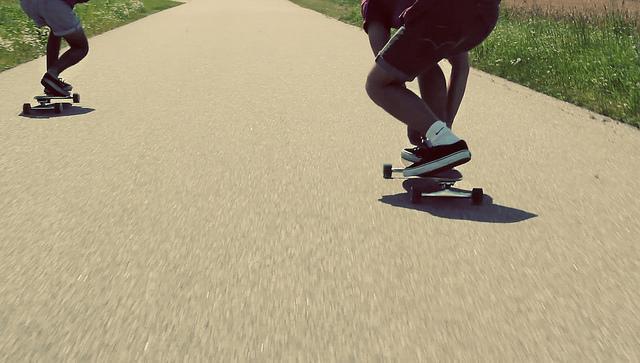How many people are there?
Give a very brief answer. 2. 